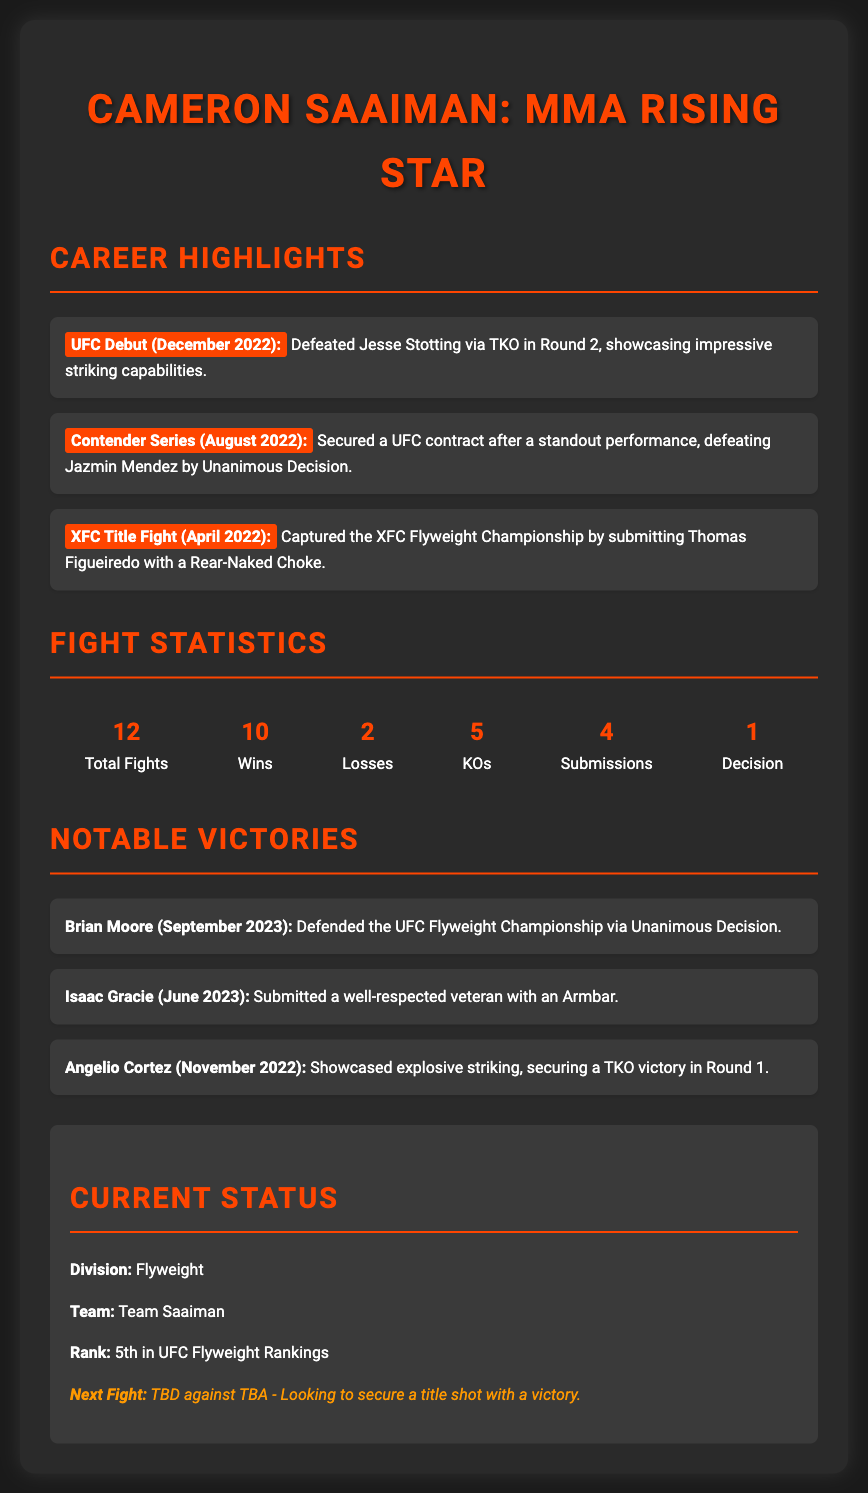What is Cameron Saaiman's total number of fights? The document specifies that Cameron Saaiman has participated in a total of 12 fights.
Answer: 12 When did Cameron Saaiman make his UFC debut? The document mentions that his UFC debut was in December 2022.
Answer: December 2022 How many wins does Cameron Saaiman have? The document states that he has achieved 10 wins in his career.
Answer: 10 Who did Cameron Saaiman defeat in his UFC debut? The document lists that he defeated Jesse Stotting in his UFC debut.
Answer: Jesse Stotting What method did Cameron Saaiman use to win the XFC Championship? The document indicates that he submitted Thomas Figueiredo with a Rear-Naked Choke.
Answer: Rear-Naked Choke How many losses does Cameron Saaiman have? The document clearly states he has 2 losses in his record.
Answer: 2 Who was Cameron Saaiman's opponent in September 2023? The document reveals that he defended the UFC Flyweight Championship against Brian Moore.
Answer: Brian Moore What is Cameron Saaiman's current rank in the UFC Flyweight Rankings? The document states that he is currently ranked 5th in the UFC Flyweight Rankings.
Answer: 5th What is the next fight status for Cameron Saaiman? The document mentions that his next fight is To Be Determined against To Be Announced.
Answer: TBD against TBA 